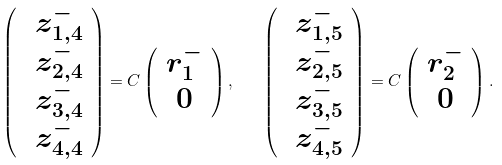<formula> <loc_0><loc_0><loc_500><loc_500>\left ( \begin{array} { c } \ z _ { 1 , 4 } ^ { - } \\ \ z _ { 2 , 4 } ^ { - } \\ \ z _ { 3 , 4 } ^ { - } \\ \ z _ { 4 , 4 } ^ { - } \end{array} \right ) = C \left ( \begin{array} { c } r _ { 1 } ^ { - } \\ 0 \end{array} \right ) , \quad \left ( \begin{array} { c } \ z _ { 1 , 5 } ^ { - } \\ \ z _ { 2 , 5 } ^ { - } \\ \ z _ { 3 , 5 } ^ { - } \\ \ z _ { 4 , 5 } ^ { - } \end{array} \right ) = C \left ( \begin{array} { c } r _ { 2 } ^ { - } \\ 0 \end{array} \right ) .</formula> 